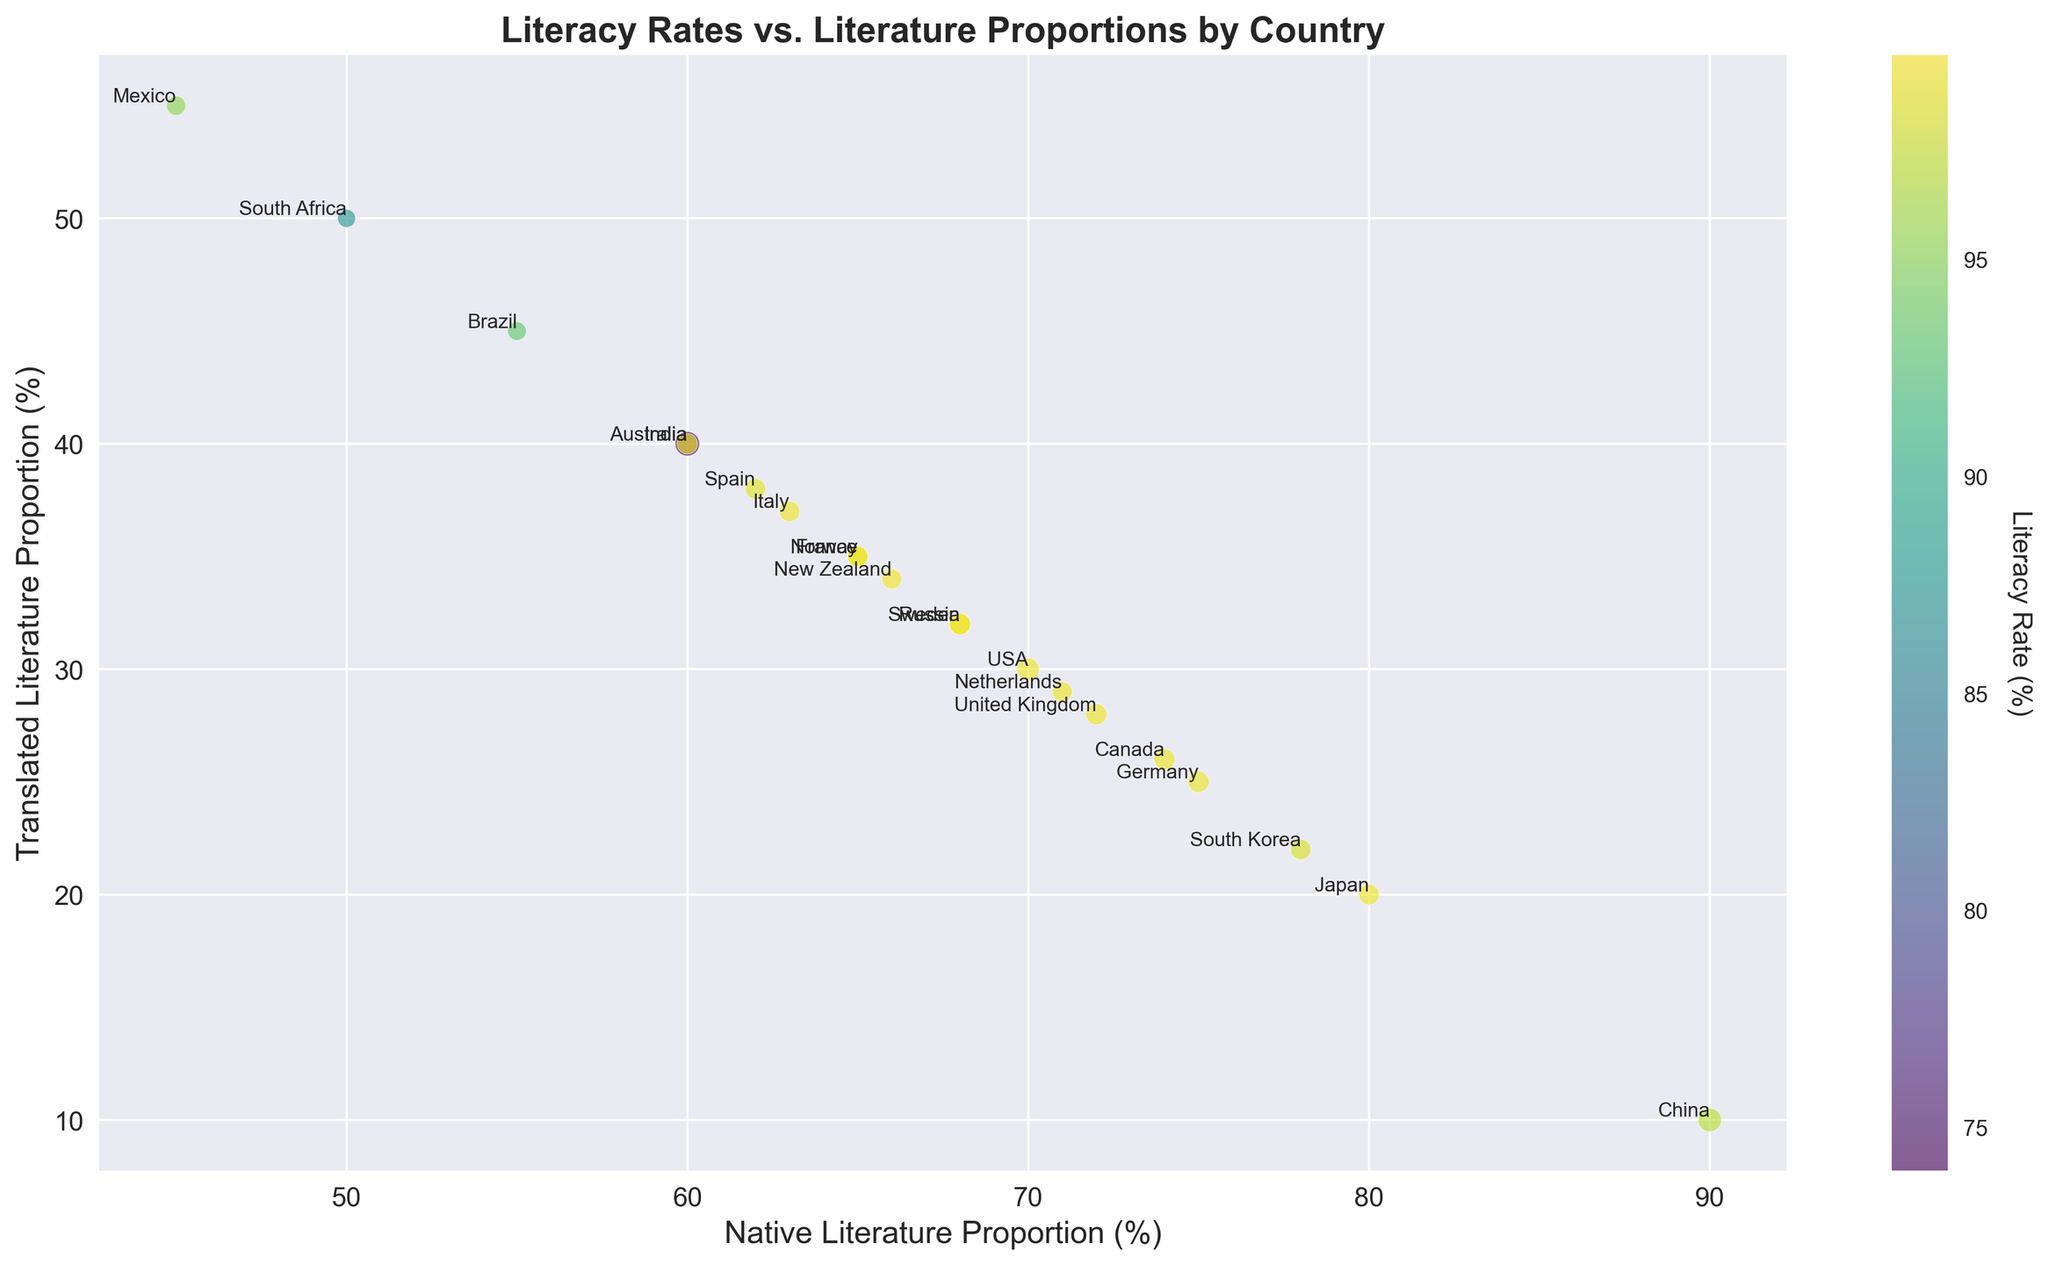Which country has the highest proportion of translated literature read? By examining the x and y axes of the bubble chart, we can identify Mexico as the country with the highest proportion of translated literature read by reading the value from the y-axis since it indicates the proportion of translated literature.
Answer: Mexico Which country has the lowest literacy rate and how does its proportion of native and translated literature compare? South Africa has the lowest literacy rate, and by looking at its position, it has an equal proportion of native and translated literature (each at 50%).
Answer: South Africa has equal proportions of native and translated literature How does the proportion of translated literature in the USA compare to that in Japan? The USA has approximately 30% translated literature, while Japan has about 20%. By comparing the y-axis values, we can see that Japan has less translated literature than the USA.
Answer: USA has 10% more translated literature than Japan Which country reads the highest proportion of native literature, and does this have any correlation with its literacy rate? By inspecting the points on the x-axis, China reads the highest proportion of native literature at about 90%. China also has a high literacy rate of 96.8%, indicating a potential positive correlation.
Answer: China reads the highest proportion of native literature and has a high literacy rate What is the average literacy rate for countries with a translated literature proportion above 40%? We need to identify countries above 40% translated literature: India (40%), Brazil (45%), Mexico (55%), South Africa (50%). The literacy rates are 74, 93, 95, 87, respectively. The average is (74 + 93 + 95 + 87) / 4 = 349 / 4 = 87.25.
Answer: 87.25 Compare the countries with literacy rates below 90% in terms of their native and translated literature proportions. The countries with literacy rates below 90% are India (74%), Brazil (93%), and South Africa (87%). India has 60% native and 40% translated literature, Brazil has 55% native and 45% translated, and South Africa has 50% native and 50% translated.
Answer: Variations exist in the proportions of native and translated literature among these countries Is there a visible trend between literacy rates and the proportion of native literature read? By examining the chart, countries with high literacy rates tend to have a higher proportion of native literature read. For instance, Japan, Germany, and the USA show high literacy rates alongside a high proportion of native literature, while countries with lower native literature proportions like Mexico and South Africa have moderate literacy rates.
Answer: High literacy rates generally correlate with a higher proportion of native literature read Which country has the smallest bubble size and what does it signify about the data point? Brazil has the smallest bubble size, signifying it has the smallest combination of the given parameters used to determine the bubble size in relation to the other countries.
Answer: Brazil 